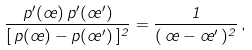Convert formula to latex. <formula><loc_0><loc_0><loc_500><loc_500>\frac { p ^ { \prime } ( \sigma ) \, p ^ { \prime } ( \sigma ^ { \prime } ) } { [ \, p ( \sigma ) - p ( \sigma ^ { \prime } ) \, ] ^ { 2 } } = \frac { 1 } { ( \, \sigma - \sigma ^ { \prime } \, ) ^ { 2 } } \, ,</formula> 